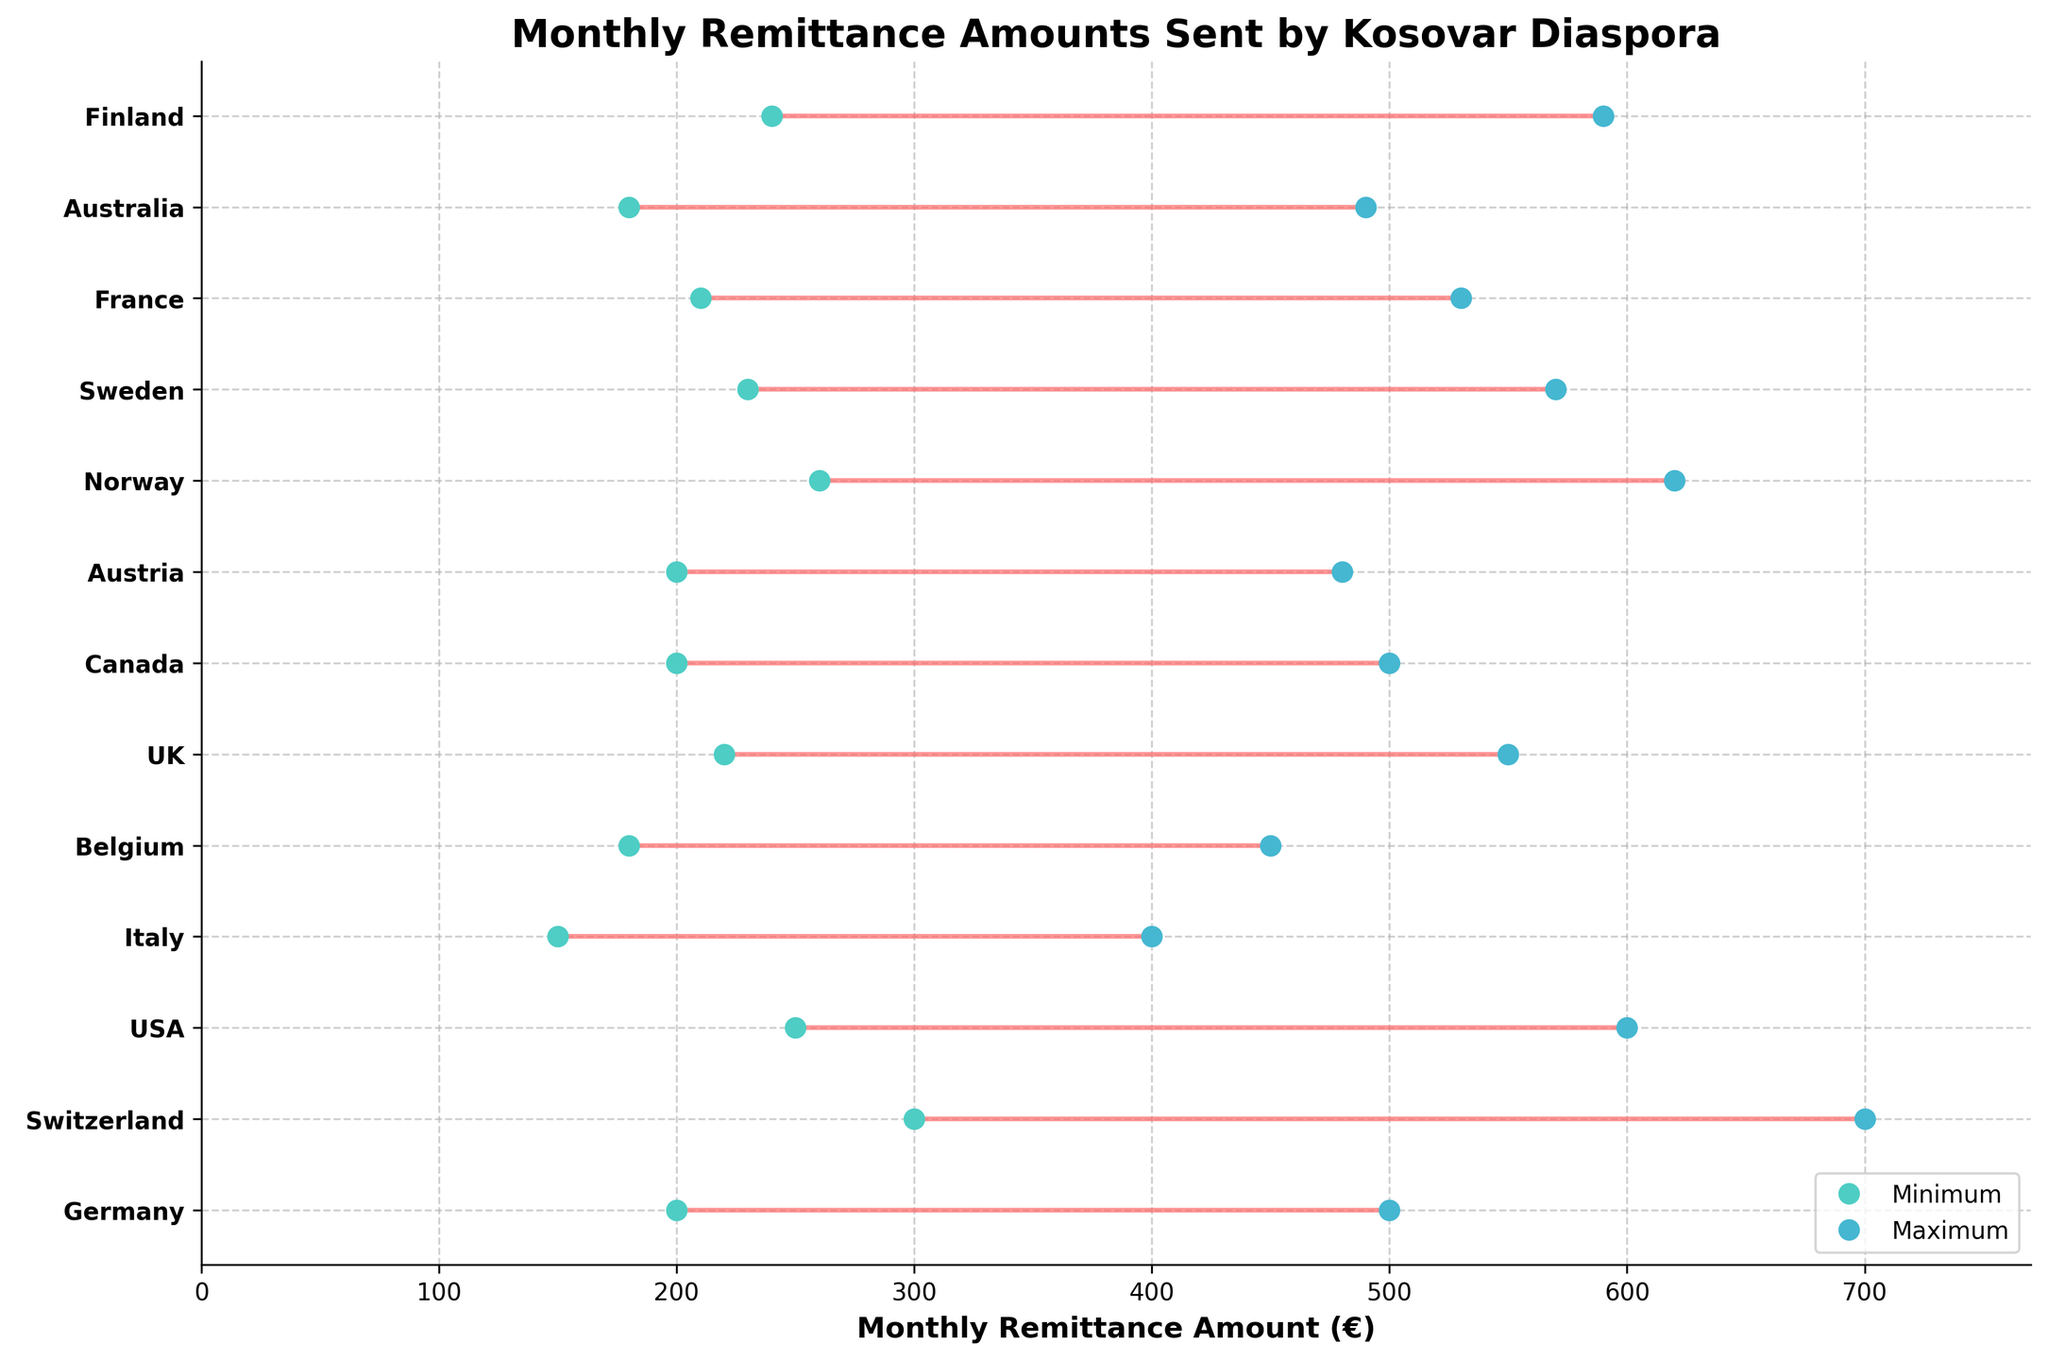what is the title of the plot? The title of the plot is present at the top of the figure and provides a purpose or overview of what the data represents. It reads: "Monthly Remittance Amounts Sent by Kosovar Diaspora".
Answer: Monthly Remittance Amounts Sent by Kosovar Diaspora What does the x-axis represent? The x-axis label is a textual description found along the horizontal axis of the plot. It represents the monetary amounts of the remittances in euros (€).
Answer: Monthly Remittance Amount (€) Which country has the highest maximum remittance amount? By examining the highest values on the x-axis and their corresponding countries, Switzerland has the highest maximum remittance value at €700.
Answer: Switzerland How many remitters send at least €250 as the minimum remittance amount? By identifying the minimum amounts of €250 or more from the plot, the remitters are Elira (USA), Luljeta (Norway), Shqipë (Sweden), and Adem (Finland). That makes four remitters.
Answer: 4 Compare the range of remittance amounts sent by Arbër and Besnik. Which range is larger? Arbër sends between €200 and €500, resulting in a range of €300. Besnik sends between €200 and €480, resulting in a range of €280. Arbër has the larger range.
Answer: Arbër What is the average of the maximum remittance amounts sent by Arbër and Blerta? Arbër's maximum remittance is €500, and Blerta's is €490. The average is calculated as (500 + 490) / 2 = €495.
Answer: €495 Which country’s remitters have the smallest range of remittance amounts? By comparing the difference between the maximum and minimum amounts for each country visually, Belgium (represented by Faton) has the smallest range of €270 (€450 - €180).
Answer: Belgium What is the difference between the maximum remittance values sent by Valon and Dafina? Valon's maximum remittance is €530, while Dafina's maximum is €400. The difference is 530 - 400 = €130.
Answer: €130 List all the countries where the minimum remittance amounts are above €200. Identifying all minimum values above €200, the countries are Germany, Switzerland, USA, UK, Canada, Norway, Sweden, France, and Finland.
Answer: Germany, Switzerland, USA, UK, Canada, Norway, Sweden, France, Finland Which remitter sends the lowest minimum remittance amount, and what is that amount? By inspecting the lowest end of the remittance ranges, Dafina (Italy) sends the lowest minimum amount of €150.
Answer: Dafina, €150 